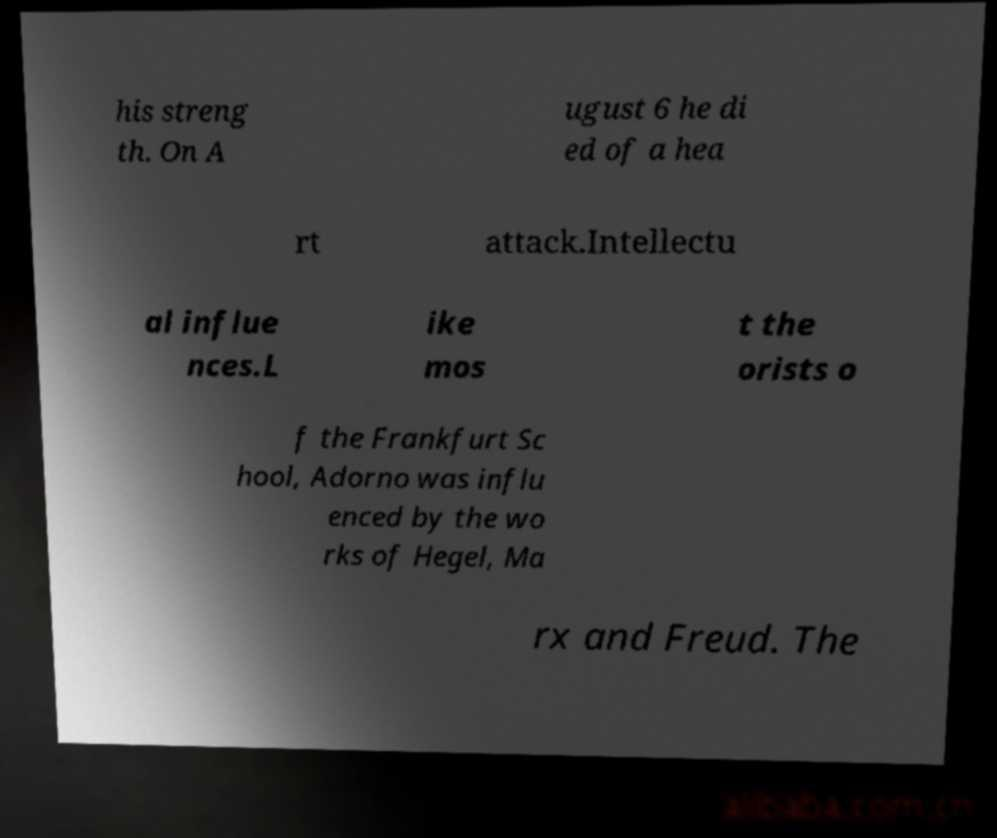Could you extract and type out the text from this image? his streng th. On A ugust 6 he di ed of a hea rt attack.Intellectu al influe nces.L ike mos t the orists o f the Frankfurt Sc hool, Adorno was influ enced by the wo rks of Hegel, Ma rx and Freud. The 